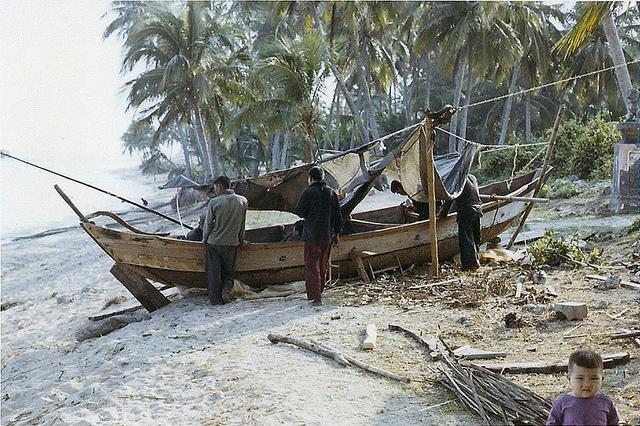Who is in the front right corner? Please explain your reasoning. little child. There is a little boy in the right corner. 